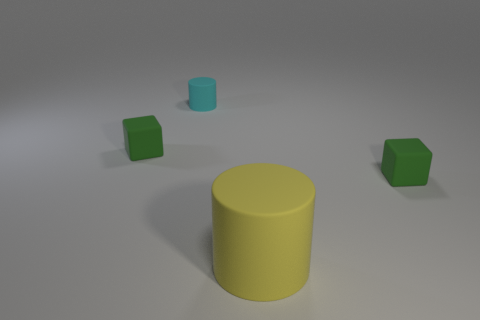Add 3 cyan rubber cylinders. How many objects exist? 7 Subtract all cyan cylinders. How many cylinders are left? 1 Add 2 green metallic objects. How many green metallic objects exist? 2 Subtract 0 brown cubes. How many objects are left? 4 Subtract 2 blocks. How many blocks are left? 0 Subtract all yellow cylinders. Subtract all blue cubes. How many cylinders are left? 1 Subtract all red spheres. How many yellow cylinders are left? 1 Subtract all yellow cylinders. Subtract all yellow metallic balls. How many objects are left? 3 Add 1 yellow objects. How many yellow objects are left? 2 